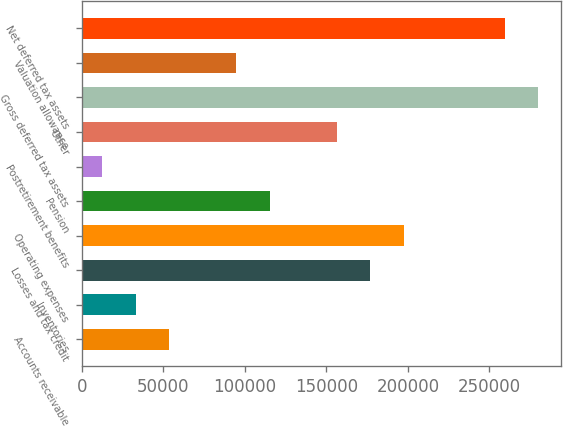<chart> <loc_0><loc_0><loc_500><loc_500><bar_chart><fcel>Accounts receivable<fcel>Inventories<fcel>Losses and tax credit<fcel>Operating expenses<fcel>Pension<fcel>Postretirement benefits<fcel>Other<fcel>Gross deferred tax assets<fcel>Valuation allowance<fcel>Net deferred tax assets<nl><fcel>53559.6<fcel>32986.8<fcel>176996<fcel>197569<fcel>115278<fcel>12414<fcel>156424<fcel>279860<fcel>94705.2<fcel>259288<nl></chart> 